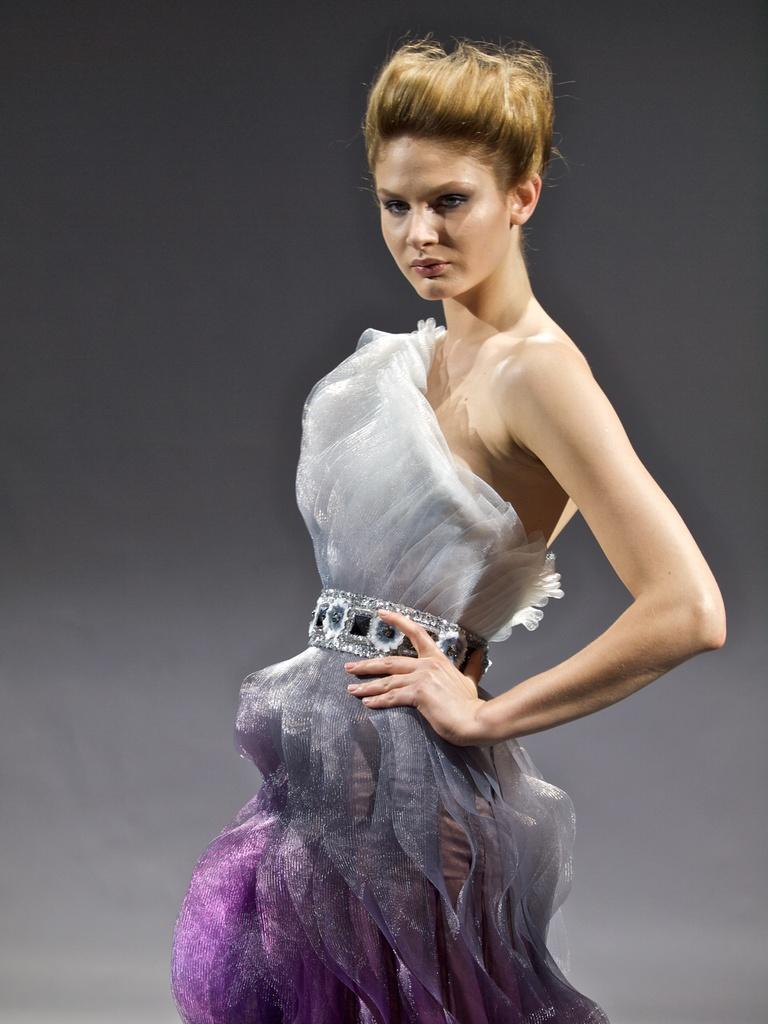Where was the image taken? The image was taken indoors. What color is the background of the image? The background of the image is gray in color. Can you describe the main subject in the image? There is a woman standing in the middle of the image. What type of eggnog can be seen in the woman's hand in the image? There is no eggnog present in the image; the woman is not holding anything. 